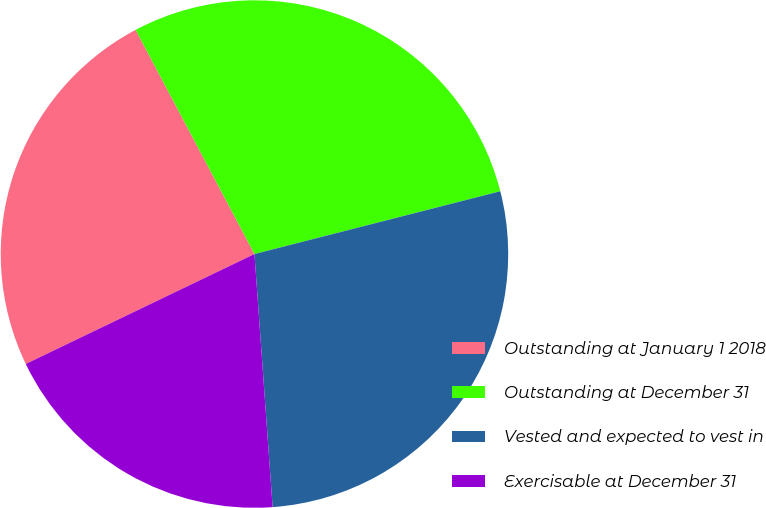<chart> <loc_0><loc_0><loc_500><loc_500><pie_chart><fcel>Outstanding at January 1 2018<fcel>Outstanding at December 31<fcel>Vested and expected to vest in<fcel>Exercisable at December 31<nl><fcel>24.37%<fcel>28.78%<fcel>27.84%<fcel>19.01%<nl></chart> 